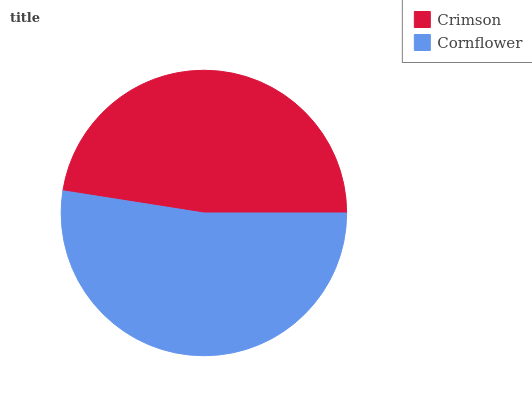Is Crimson the minimum?
Answer yes or no. Yes. Is Cornflower the maximum?
Answer yes or no. Yes. Is Cornflower the minimum?
Answer yes or no. No. Is Cornflower greater than Crimson?
Answer yes or no. Yes. Is Crimson less than Cornflower?
Answer yes or no. Yes. Is Crimson greater than Cornflower?
Answer yes or no. No. Is Cornflower less than Crimson?
Answer yes or no. No. Is Cornflower the high median?
Answer yes or no. Yes. Is Crimson the low median?
Answer yes or no. Yes. Is Crimson the high median?
Answer yes or no. No. Is Cornflower the low median?
Answer yes or no. No. 